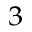Convert formula to latex. <formula><loc_0><loc_0><loc_500><loc_500>^ { 3 }</formula> 